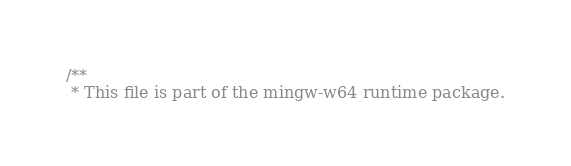Convert code to text. <code><loc_0><loc_0><loc_500><loc_500><_C_>/**
 * This file is part of the mingw-w64 runtime package.</code> 